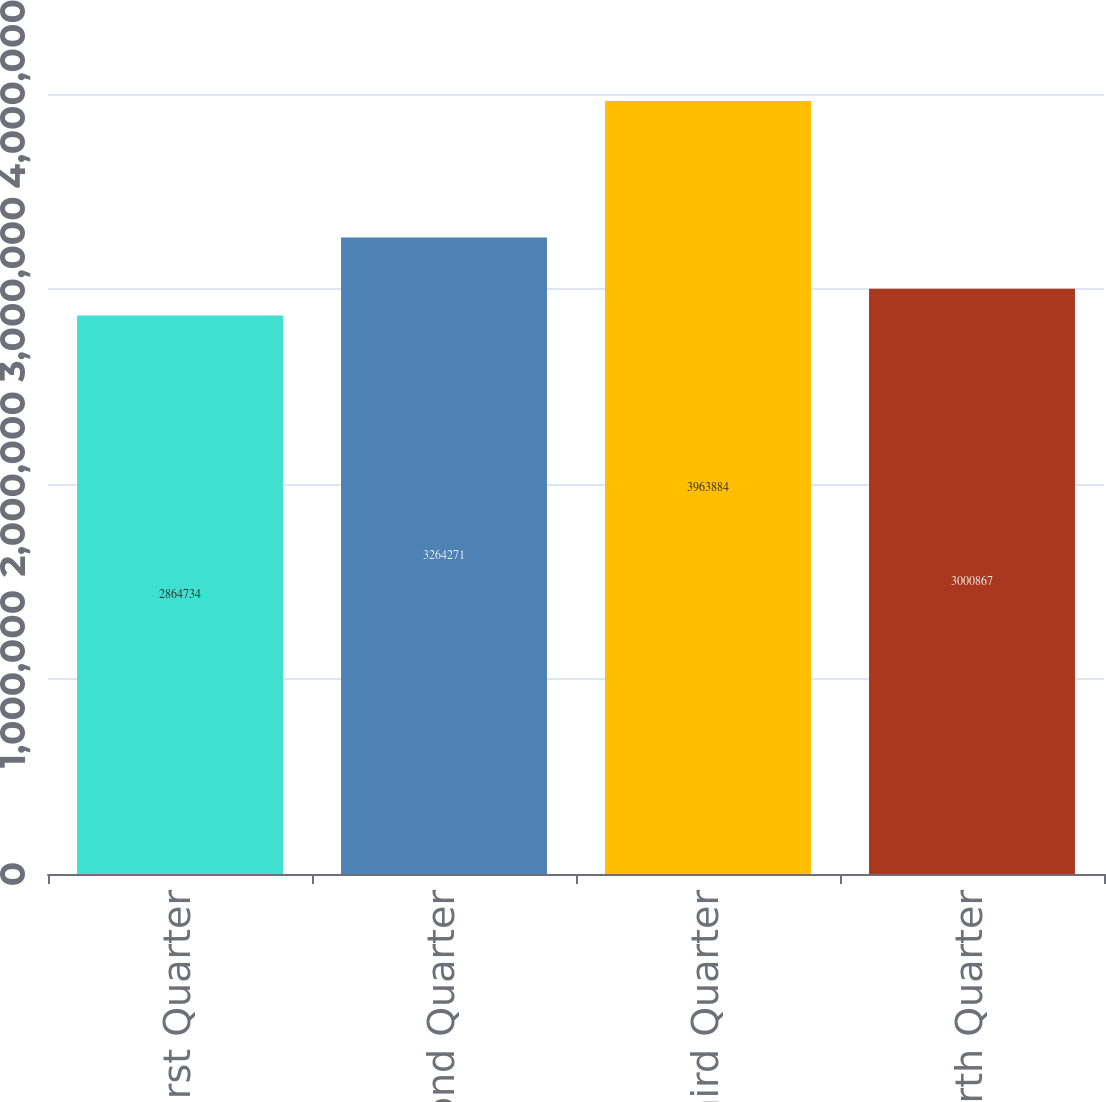Convert chart. <chart><loc_0><loc_0><loc_500><loc_500><bar_chart><fcel>First Quarter<fcel>Second Quarter<fcel>Third Quarter<fcel>Fourth Quarter<nl><fcel>2.86473e+06<fcel>3.26427e+06<fcel>3.96388e+06<fcel>3.00087e+06<nl></chart> 